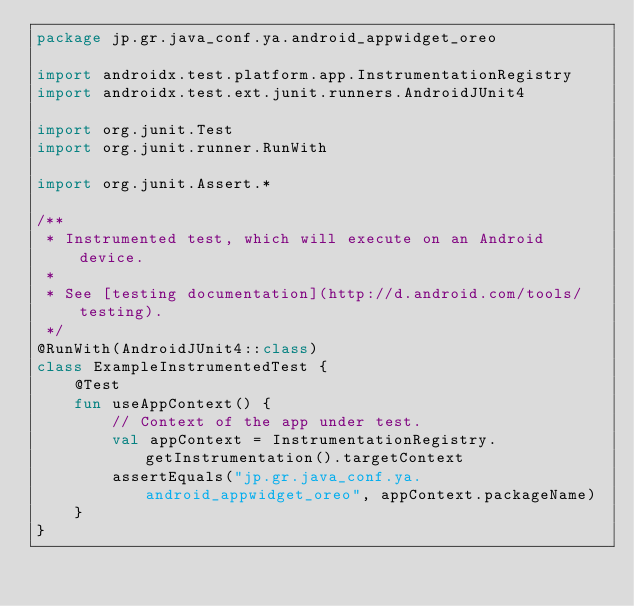<code> <loc_0><loc_0><loc_500><loc_500><_Kotlin_>package jp.gr.java_conf.ya.android_appwidget_oreo

import androidx.test.platform.app.InstrumentationRegistry
import androidx.test.ext.junit.runners.AndroidJUnit4

import org.junit.Test
import org.junit.runner.RunWith

import org.junit.Assert.*

/**
 * Instrumented test, which will execute on an Android device.
 *
 * See [testing documentation](http://d.android.com/tools/testing).
 */
@RunWith(AndroidJUnit4::class)
class ExampleInstrumentedTest {
    @Test
    fun useAppContext() {
        // Context of the app under test.
        val appContext = InstrumentationRegistry.getInstrumentation().targetContext
        assertEquals("jp.gr.java_conf.ya.android_appwidget_oreo", appContext.packageName)
    }
}
</code> 